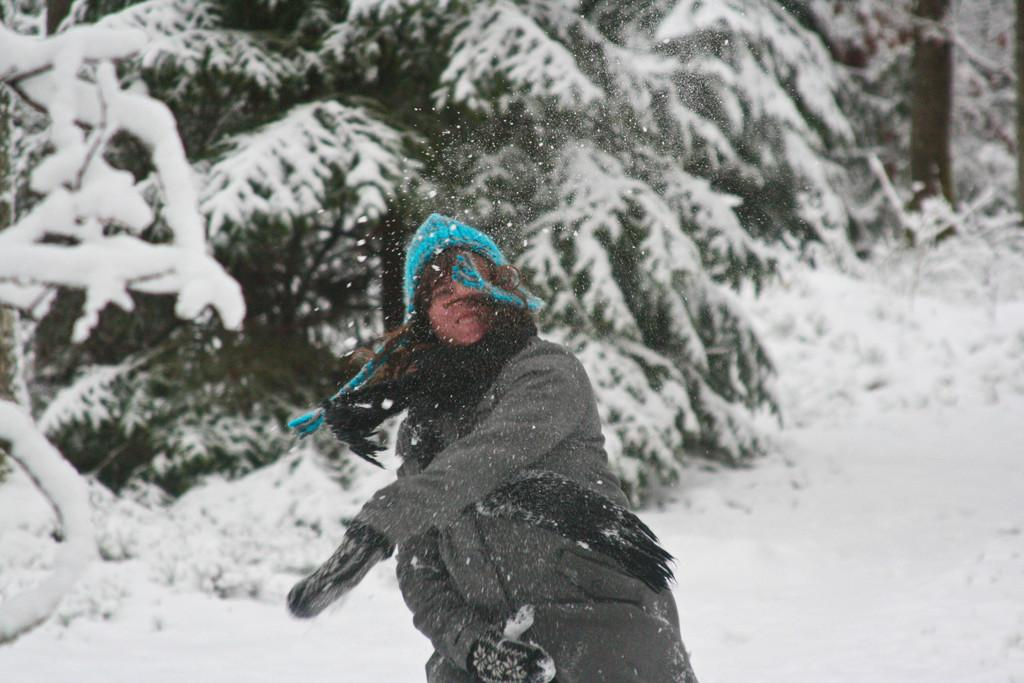Who is the main subject in the image? There is a person in the center of the image. What type of clothing is the person wearing? The person is wearing a coat, a scarf, and a cap. What can be seen in the background of the image? There are trees in the background of the image. How is the weather depicted in the image? The trees are covered by snow, and there is snow at the bottom of the image. What type of sound can be heard coming from the scarecrow in the image? There is no scarecrow present in the image, so it is not possible to determine what sound might be coming from it. 